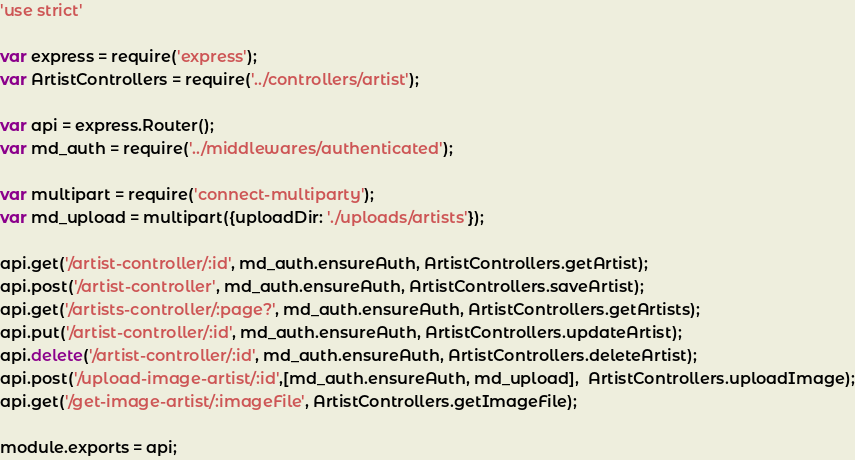<code> <loc_0><loc_0><loc_500><loc_500><_JavaScript_>'use strict'

var express = require('express');
var ArtistControllers = require('../controllers/artist');

var api = express.Router();
var md_auth = require('../middlewares/authenticated');

var multipart = require('connect-multiparty');
var md_upload = multipart({uploadDir: './uploads/artists'});

api.get('/artist-controller/:id', md_auth.ensureAuth, ArtistControllers.getArtist);
api.post('/artist-controller', md_auth.ensureAuth, ArtistControllers.saveArtist);
api.get('/artists-controller/:page?', md_auth.ensureAuth, ArtistControllers.getArtists);
api.put('/artist-controller/:id', md_auth.ensureAuth, ArtistControllers.updateArtist);
api.delete('/artist-controller/:id', md_auth.ensureAuth, ArtistControllers.deleteArtist);
api.post('/upload-image-artist/:id',[md_auth.ensureAuth, md_upload],  ArtistControllers.uploadImage);
api.get('/get-image-artist/:imageFile', ArtistControllers.getImageFile);

module.exports = api;</code> 